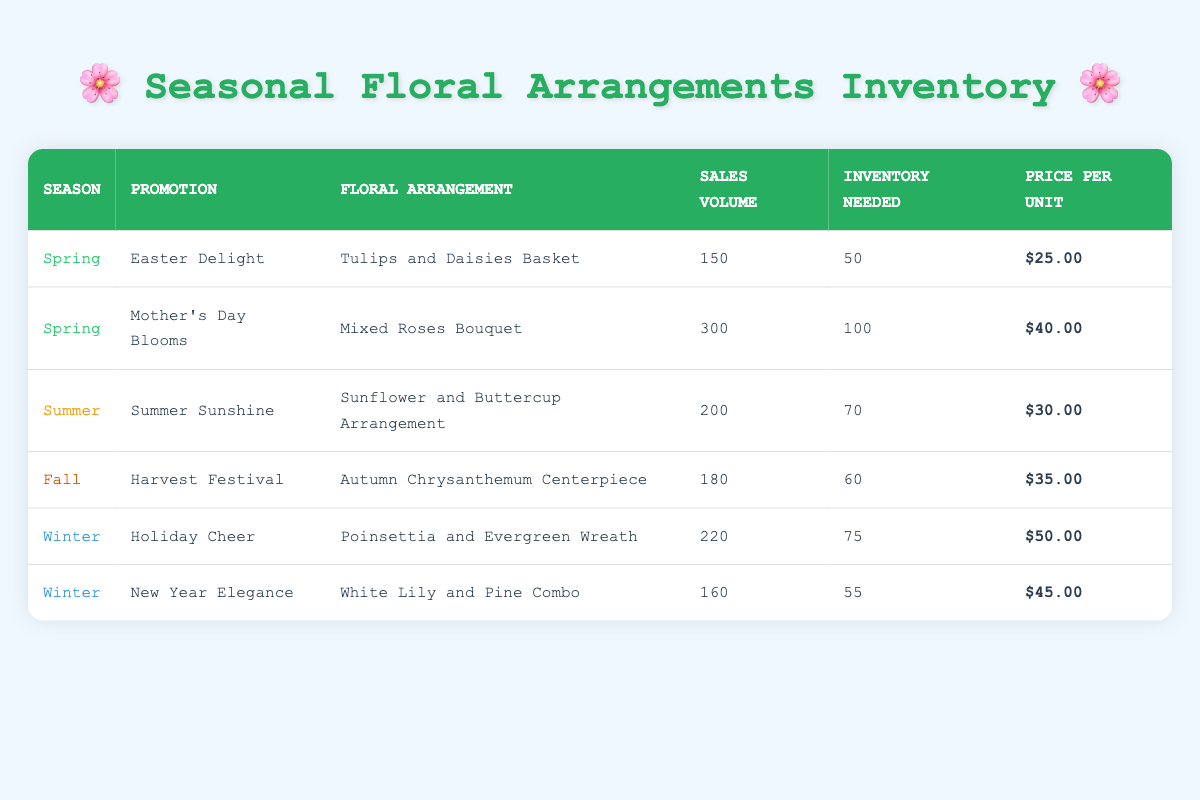What floral arrangement had the highest sales volume during seasonal promotions? By scanning through the table, the "Mixed Roses Bouquet" from the "Mother's Day Blooms" promotion has the highest sales volume of 300 units.
Answer: Mixed Roses Bouquet How many floral arrangements had a sales volume of over 200? There are two arrangements with sales volume over 200: "Mixed Roses Bouquet" (300) and "Poinsettia and Evergreen Wreath" (220).
Answer: 2 Which season had the least sales volume overall summed up across all promotions? To find this, I sum the sales volumes for each season: Spring (150 + 300 = 450), Summer (200), Fall (180), and Winter (220 + 160 = 380). The least is Winter at 380.
Answer: Winter Did "Tulips and Daisies Basket" sell more than "Autumn Chrysanthemum Centerpiece"? The "Tulips and Daisies Basket" sold 150 units, while the "Autumn Chrysanthemum Centerpiece" sold 180 units. Thus, it is false that the basket sold more.
Answer: No What is the total inventory needed for all promotions during the Spring season? The inventory needed for Spring arrangements are: 50 (Easter Delight) + 100 (Mother's Day Blooms) = 150. So, the total inventory needed for Spring is 150.
Answer: 150 Which promotion in Winter has a higher price per unit? Comparing the "Holiday Cheer" priced at $50.00 and the "New Year Elegance" priced at $45.00, the "Holiday Cheer" has the higher price per unit.
Answer: Holiday Cheer What is the average sales volume for the Summer season? The sales volume for Summer is 200 from the "Sunflower and Buttercup Arrangement". Since there is only one entry, the average is 200/1 = 200.
Answer: 200 How many more units did "Poinsettia and Evergreen Wreath" sell than "White Lily and Pine Combo"? The "Poinsettia and Evergreen Wreath" sold 220 units, while the "White Lily and Pine Combo" sold 160 units. The difference is 220 - 160 = 60.
Answer: 60 What floral arrangement has the highest price per unit and what is that price? Checking prices, the "Poinsettia and Evergreen Wreath" has the highest price at $50.00 per unit.
Answer: Poinsettia and Evergreen Wreath, $50.00 